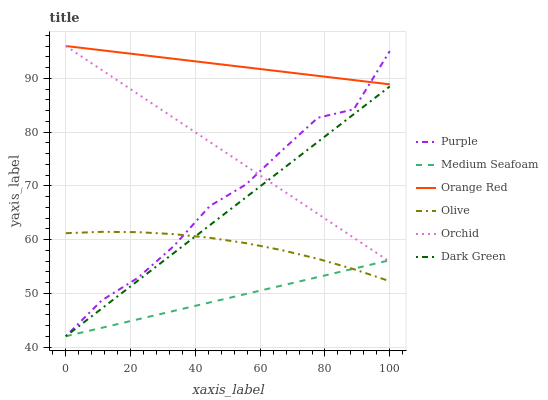Does Medium Seafoam have the minimum area under the curve?
Answer yes or no. Yes. Does Orange Red have the maximum area under the curve?
Answer yes or no. Yes. Does Olive have the minimum area under the curve?
Answer yes or no. No. Does Olive have the maximum area under the curve?
Answer yes or no. No. Is Medium Seafoam the smoothest?
Answer yes or no. Yes. Is Purple the roughest?
Answer yes or no. Yes. Is Orange Red the smoothest?
Answer yes or no. No. Is Orange Red the roughest?
Answer yes or no. No. Does Olive have the lowest value?
Answer yes or no. No. Does Orchid have the highest value?
Answer yes or no. Yes. Does Olive have the highest value?
Answer yes or no. No. Is Olive less than Orange Red?
Answer yes or no. Yes. Is Orange Red greater than Dark Green?
Answer yes or no. Yes. Does Olive intersect Orange Red?
Answer yes or no. No. 